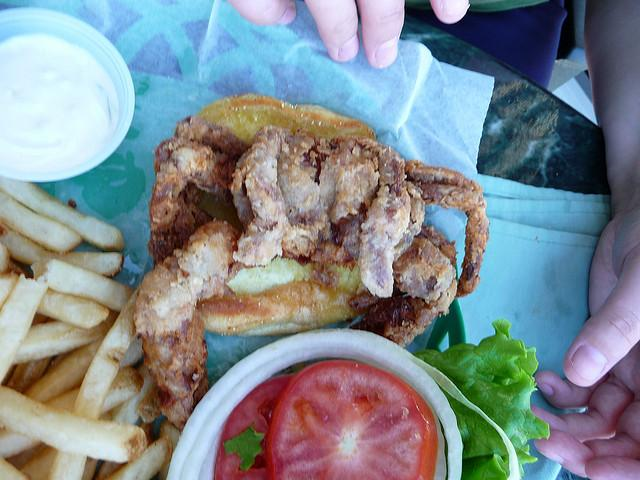What is being dissected here? Please explain your reasoning. sandwich. The sandwich has been split apart. 